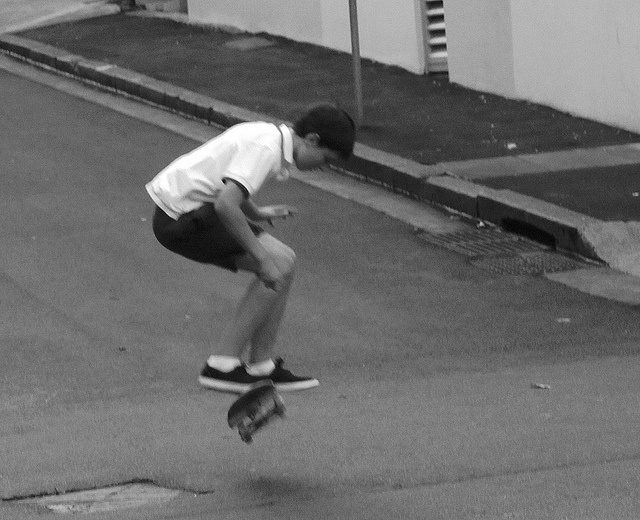Describe the objects in this image and their specific colors. I can see people in darkgray, black, gray, and lightgray tones and skateboard in gray, black, and darkgray tones in this image. 